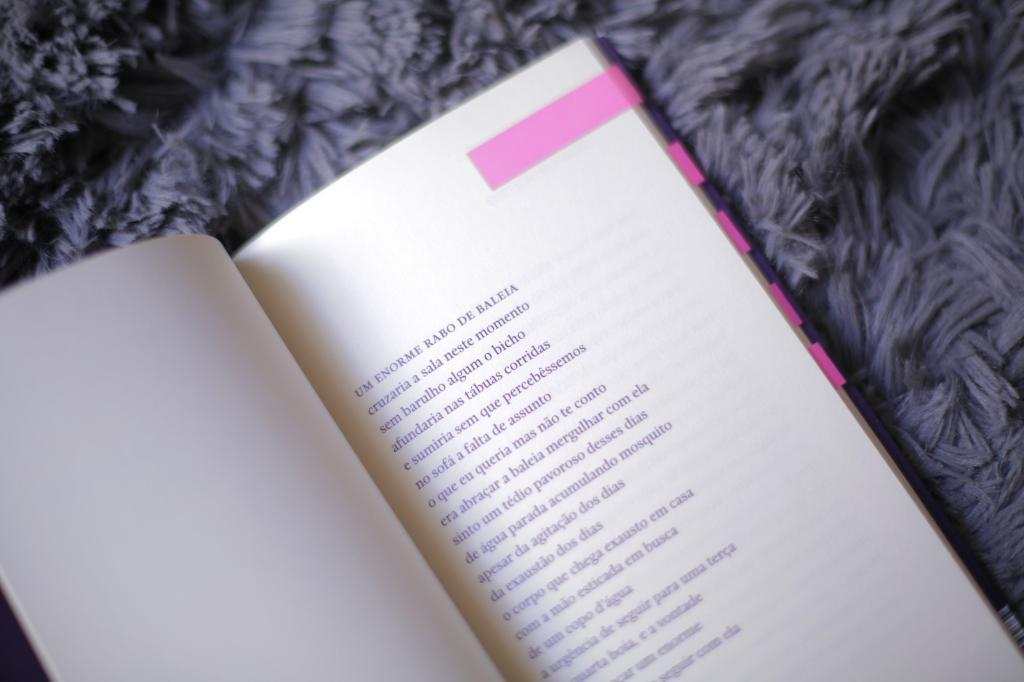Provide a one-sentence caption for the provided image. a book with the word BALEIA at the end of the first line. 